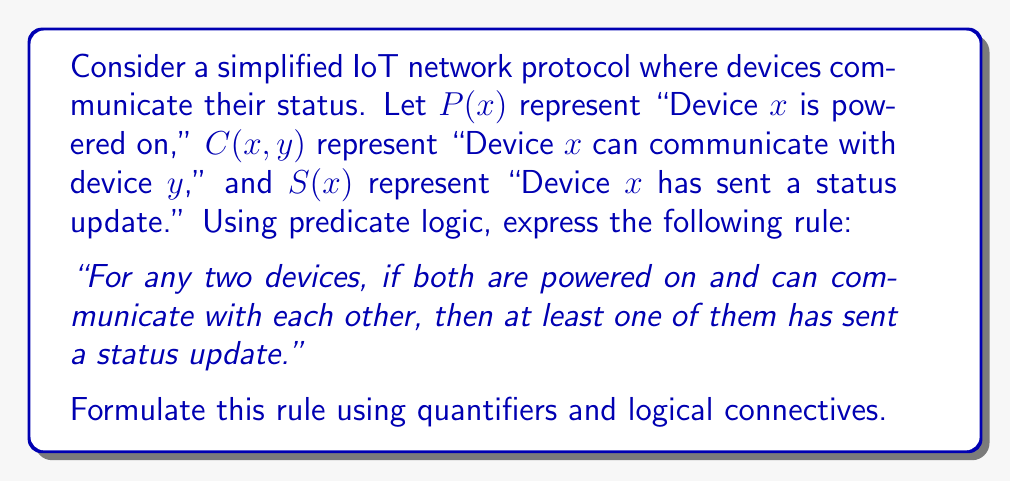Can you solve this math problem? To formulate this rule using predicate logic, we need to break it down into its components and use appropriate quantifiers and logical connectives. Let's approach this step-by-step:

1. We need to quantify over two devices, so we'll use the universal quantifier $\forall$ twice:
   $\forall x \forall y$

2. The condition "if both are powered on and can communicate with each other" can be expressed as:
   $P(x) \land P(y) \land C(x,y) \land C(y,x)$

3. The conclusion "then at least one of them has sent a status update" can be expressed as:
   $S(x) \lor S(y)$

4. We connect the condition and conclusion using the implication operator $\rightarrow$

5. Putting it all together, we get:

   $$\forall x \forall y ((P(x) \land P(y) \land C(x,y) \land C(y,x)) \rightarrow (S(x) \lor S(y)))$$

This logical formula reads as: "For all devices $x$ and $y$, if $x$ is powered on and $y$ is powered on and $x$ can communicate with $y$ and $y$ can communicate with $x$, then either $x$ has sent a status update or $y$ has sent a status update."

Note that we've included $C(y,x)$ in addition to $C(x,y)$ to ensure bidirectional communication, which is often a requirement in IoT protocols for reliable data exchange.
Answer: $$\forall x \forall y ((P(x) \land P(y) \land C(x,y) \land C(y,x)) \rightarrow (S(x) \lor S(y)))$$ 